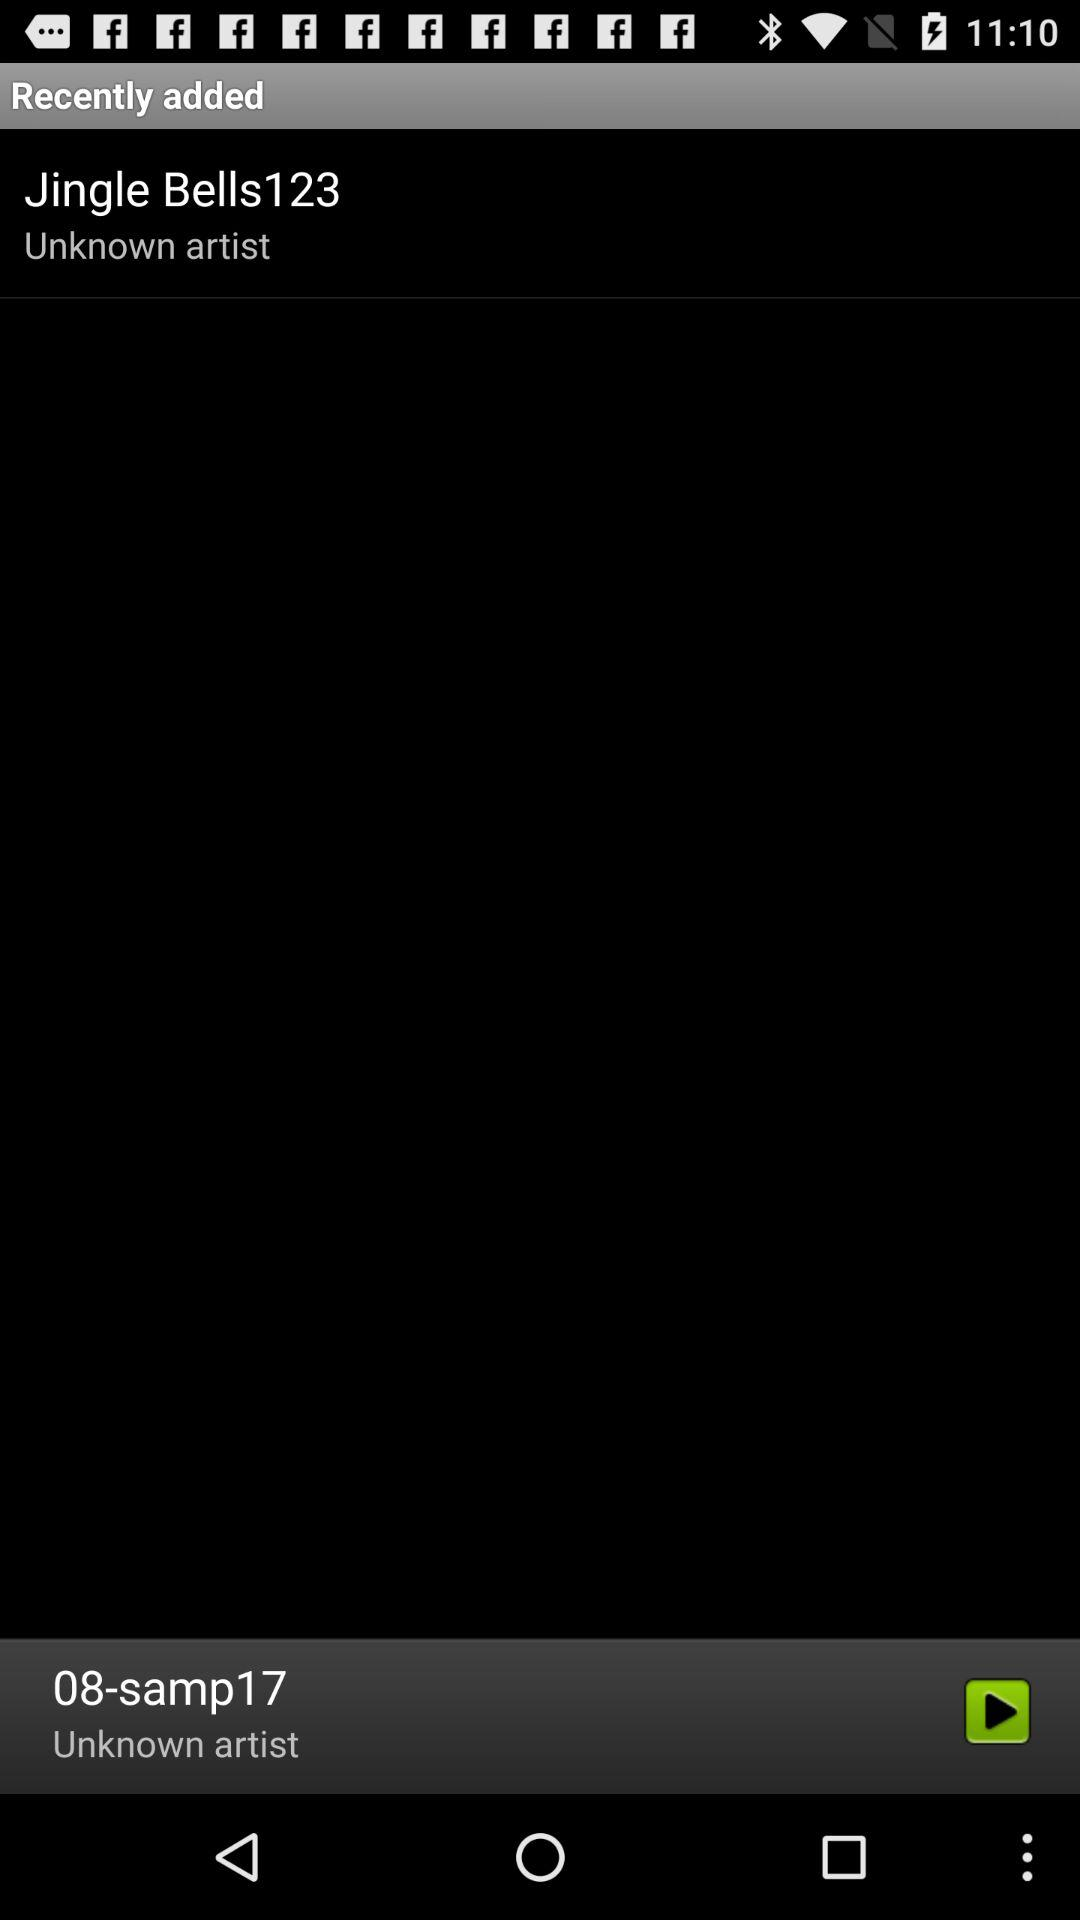What is the name of the artist of the song that is currently playing? The artist's name is unknown. 